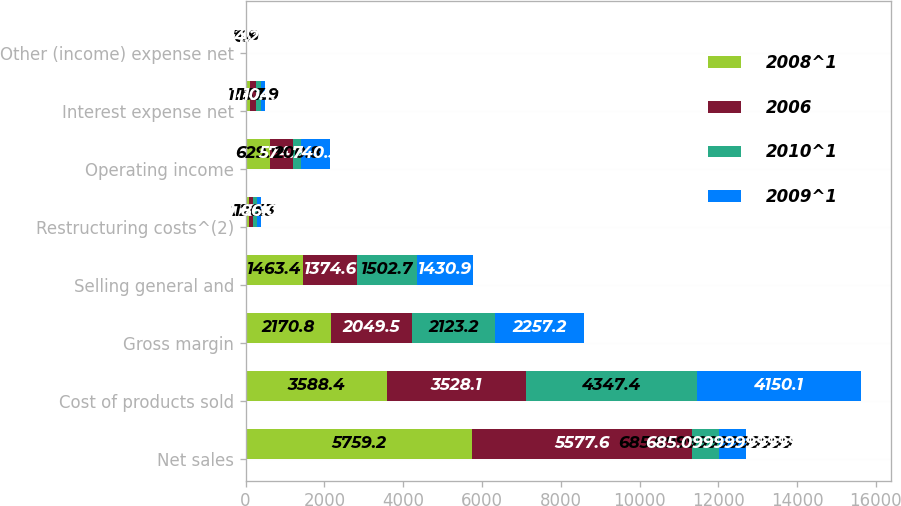Convert chart. <chart><loc_0><loc_0><loc_500><loc_500><stacked_bar_chart><ecel><fcel>Net sales<fcel>Cost of products sold<fcel>Gross margin<fcel>Selling general and<fcel>Restructuring costs^(2)<fcel>Operating income<fcel>Interest expense net<fcel>Other (income) expense net<nl><fcel>2008^1<fcel>5759.2<fcel>3588.4<fcel>2170.8<fcel>1463.4<fcel>77.5<fcel>629.9<fcel>118.4<fcel>7.4<nl><fcel>2006<fcel>5577.6<fcel>3528.1<fcel>2049.5<fcel>1374.6<fcel>100<fcel>574.9<fcel>140<fcel>2<nl><fcel>2010^1<fcel>685.1<fcel>4347.4<fcel>2123.2<fcel>1502.7<fcel>120.3<fcel>200.8<fcel>137.9<fcel>6.9<nl><fcel>2009^1<fcel>685.1<fcel>4150.1<fcel>2257.2<fcel>1430.9<fcel>86<fcel>740.3<fcel>104.1<fcel>4.2<nl></chart> 